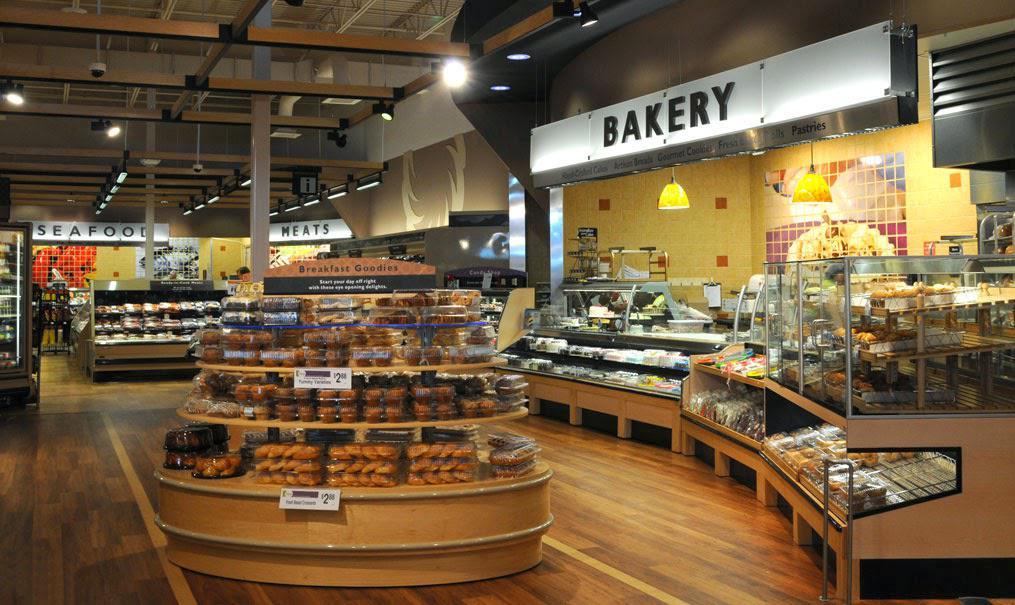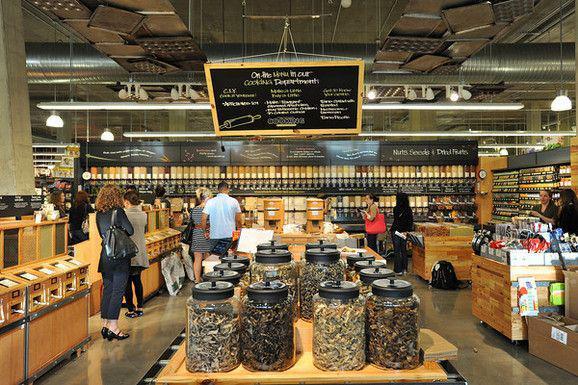The first image is the image on the left, the second image is the image on the right. Analyze the images presented: Is the assertion "Lefthand image features a bakery with a white rectangular sign with lettering only." valid? Answer yes or no. Yes. 